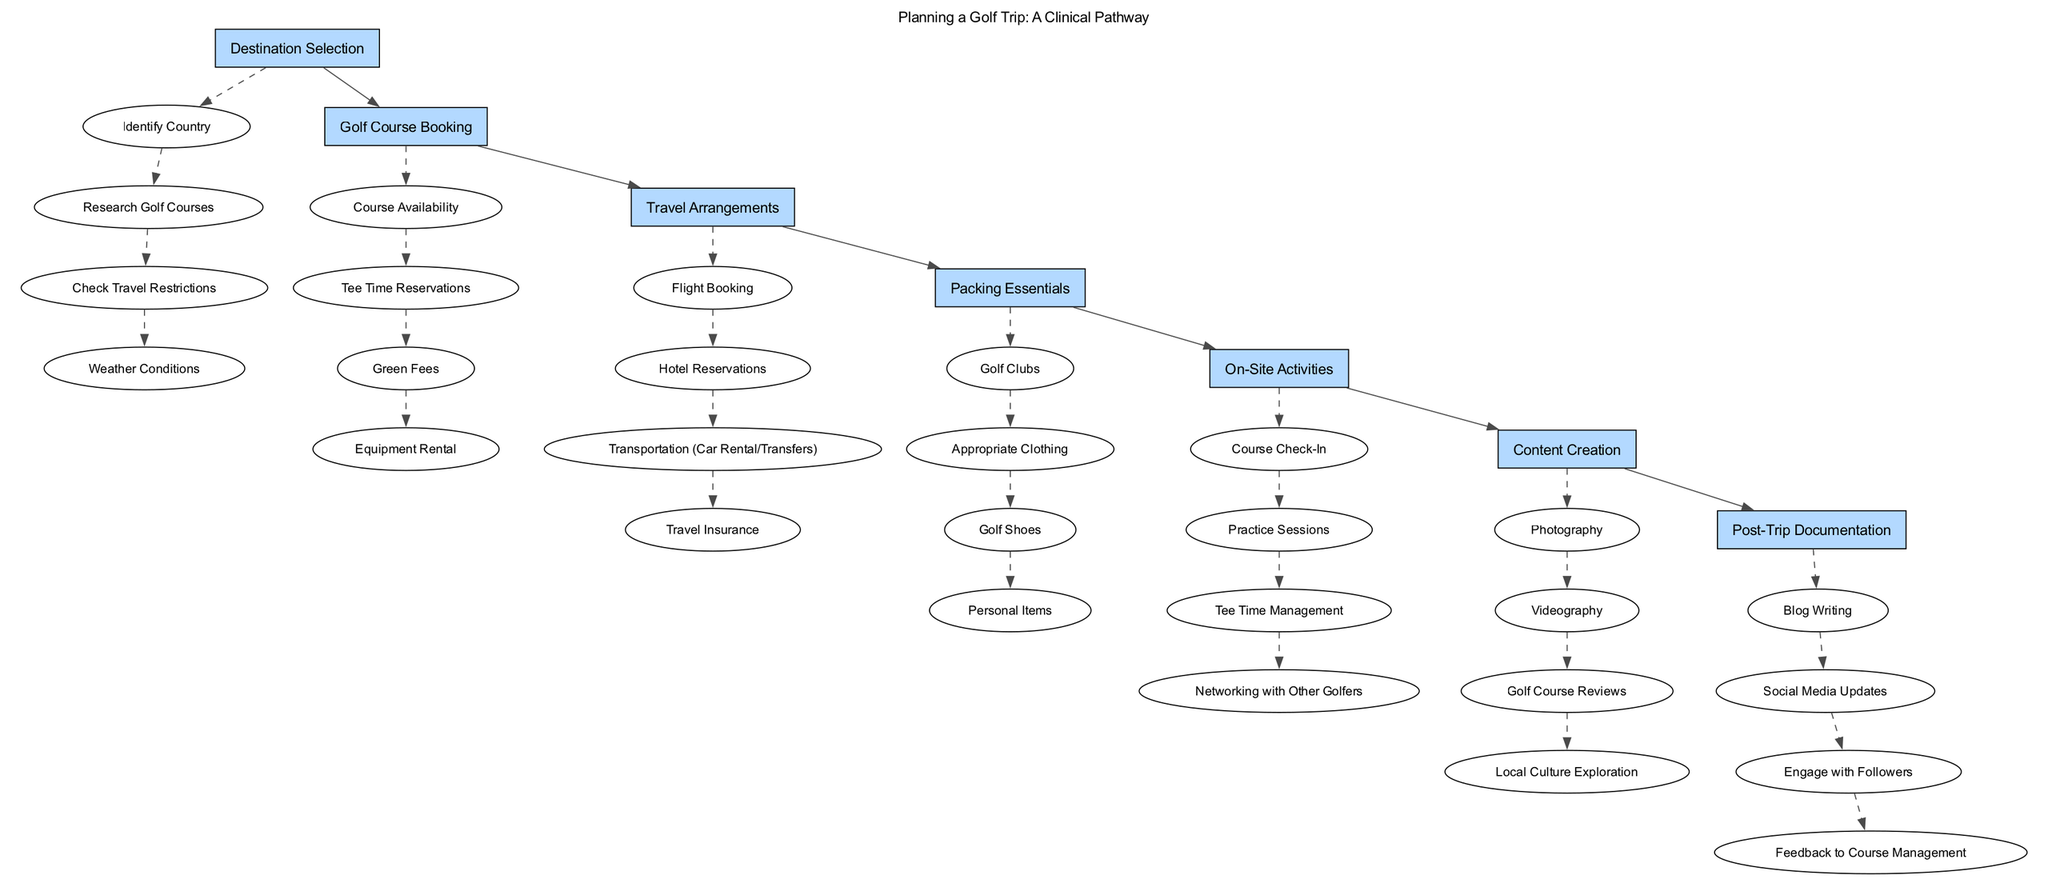What is the first step in the clinical pathway? The first step is identified as "Destination Selection". This is the initial action taken in planning the golf trip, indicating the importance of choosing where to go.
Answer: Destination Selection How many steps are there in total in the clinical pathway? By counting the listed steps in the diagram, we find there are seven distinct steps in the pathway concerning planning a golf trip.
Answer: Seven What is one of the elements under "Golf Course Booking"? One of the elements listed under "Golf Course Booking" is "Tee Time Reservations". This indicates a specific task involved in securing a spot to play golf.
Answer: Tee Time Reservations What is the main focus of the final step? The final step is "Post-Trip Documentation," which concentrated on activities related to documenting and sharing the experiences after the trip concludes.
Answer: Post-Trip Documentation Which step includes "Photography" as an element? The step that includes "Photography" is "Content Creation". This implies that capturing images is significant for sharing the travel experience.
Answer: Content Creation How do the steps flow from "Travel Arrangements" to "Packing Essentials"? The diagram shows a direct connection with an edge from "Travel Arrangements" to "Packing Essentials", indicating that once travel plans are made, packing becomes the next step in the process.
Answer: Direct connection What is the relationship between "On-Site Activities" and "Content Creation"? "On-Site Activities" precedes "Content Creation," indicating that activities during the trip inform the content produced afterward, such as reviews and explorations.
Answer: Precedes Which step has the most elements? The step "Golf Course Booking" has four elements listed under it, making it the most detailed with multiple necessary tasks.
Answer: Golf Course Booking What kind of insurance is advised during "Travel Arrangements"? "Travel Insurance" is the advised type of insurance mentioned within the "Travel Arrangements" step, highlighting its importance for safeguarding the trip.
Answer: Travel Insurance 